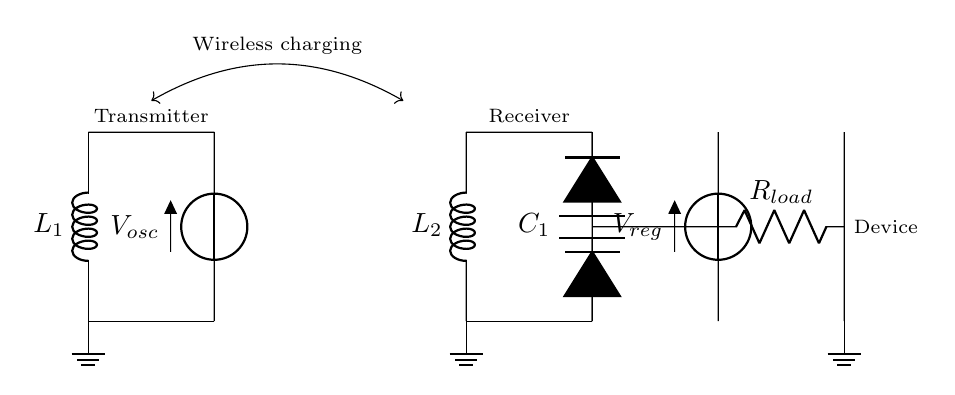What is the role of L1 in the circuit? L1 is a wireless charging coil which acts as the transmitter in the wireless charging process, creating a magnetic field that transfers energy.
Answer: Wireless charging coil What is the function of the rectifier in the circuit? The rectifier converts the alternating current induced in the receiver coil (L2) into direct current for the load.
Answer: Convert AC to DC What is the value of the load resistance R_load? R_load is a component that represents the total resistance the smartphone or wearable device presents to the circuit. The specific value isn't provided in the diagram.
Answer: Not specified What type of capacitor is used in the circuit? C1 is a smoothing capacitor that filters out the ripples from the rectified voltage to provide a stable DC voltage for the load.
Answer: Smoothing capacitor How many power sources are present in the circuit? There are two voltage sources in the circuit: one for the oscillator (V_osc) and another for the voltage regulator (V_reg).
Answer: Two What happens in the receiver coil (L2)? L2 receives the magnetic field created by the transmitter coil (L1) and induces an alternating voltage that is then rectified for use by the load.
Answer: Induces voltage Why is a voltage regulator needed in the circuit? A voltage regulator ensures that the output voltage remains stable and within the acceptable range for the load, despite fluctuations in input or load conditions.
Answer: Stabilizes output voltage 